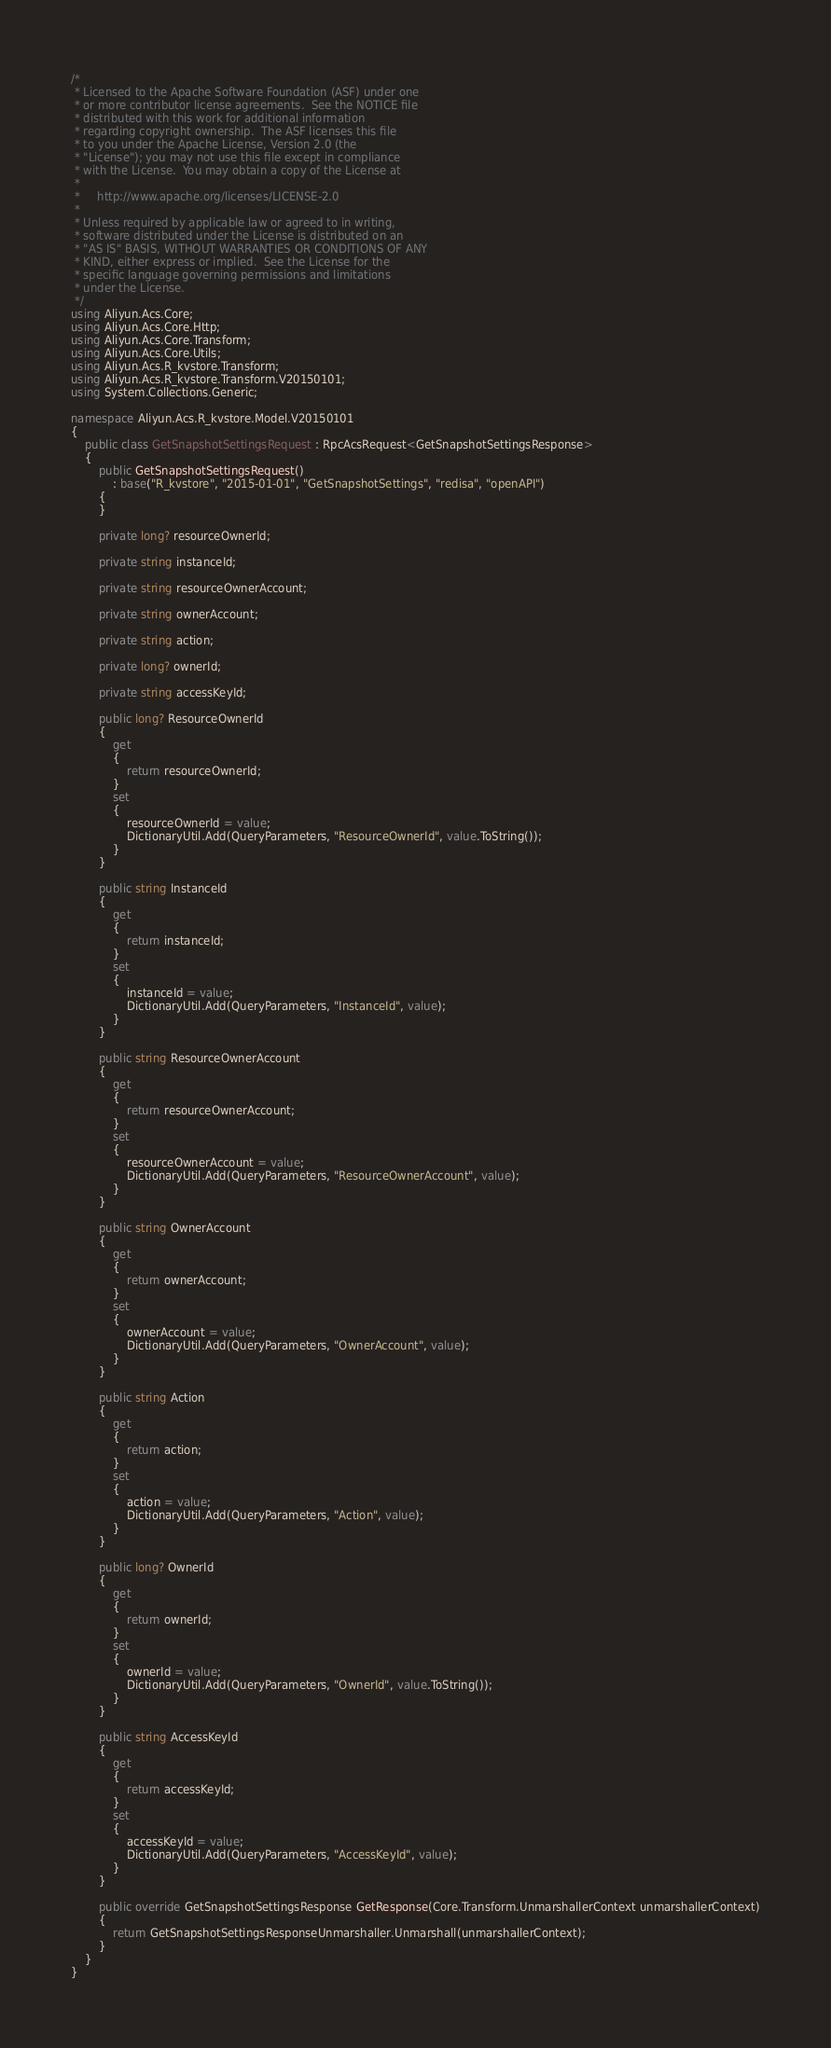<code> <loc_0><loc_0><loc_500><loc_500><_C#_>/*
 * Licensed to the Apache Software Foundation (ASF) under one
 * or more contributor license agreements.  See the NOTICE file
 * distributed with this work for additional information
 * regarding copyright ownership.  The ASF licenses this file
 * to you under the Apache License, Version 2.0 (the
 * "License"); you may not use this file except in compliance
 * with the License.  You may obtain a copy of the License at
 *
 *     http://www.apache.org/licenses/LICENSE-2.0
 *
 * Unless required by applicable law or agreed to in writing,
 * software distributed under the License is distributed on an
 * "AS IS" BASIS, WITHOUT WARRANTIES OR CONDITIONS OF ANY
 * KIND, either express or implied.  See the License for the
 * specific language governing permissions and limitations
 * under the License.
 */
using Aliyun.Acs.Core;
using Aliyun.Acs.Core.Http;
using Aliyun.Acs.Core.Transform;
using Aliyun.Acs.Core.Utils;
using Aliyun.Acs.R_kvstore.Transform;
using Aliyun.Acs.R_kvstore.Transform.V20150101;
using System.Collections.Generic;

namespace Aliyun.Acs.R_kvstore.Model.V20150101
{
    public class GetSnapshotSettingsRequest : RpcAcsRequest<GetSnapshotSettingsResponse>
    {
        public GetSnapshotSettingsRequest()
            : base("R_kvstore", "2015-01-01", "GetSnapshotSettings", "redisa", "openAPI")
        {
        }

		private long? resourceOwnerId;

		private string instanceId;

		private string resourceOwnerAccount;

		private string ownerAccount;

		private string action;

		private long? ownerId;

		private string accessKeyId;

		public long? ResourceOwnerId
		{
			get
			{
				return resourceOwnerId;
			}
			set	
			{
				resourceOwnerId = value;
				DictionaryUtil.Add(QueryParameters, "ResourceOwnerId", value.ToString());
			}
		}

		public string InstanceId
		{
			get
			{
				return instanceId;
			}
			set	
			{
				instanceId = value;
				DictionaryUtil.Add(QueryParameters, "InstanceId", value);
			}
		}

		public string ResourceOwnerAccount
		{
			get
			{
				return resourceOwnerAccount;
			}
			set	
			{
				resourceOwnerAccount = value;
				DictionaryUtil.Add(QueryParameters, "ResourceOwnerAccount", value);
			}
		}

		public string OwnerAccount
		{
			get
			{
				return ownerAccount;
			}
			set	
			{
				ownerAccount = value;
				DictionaryUtil.Add(QueryParameters, "OwnerAccount", value);
			}
		}

		public string Action
		{
			get
			{
				return action;
			}
			set	
			{
				action = value;
				DictionaryUtil.Add(QueryParameters, "Action", value);
			}
		}

		public long? OwnerId
		{
			get
			{
				return ownerId;
			}
			set	
			{
				ownerId = value;
				DictionaryUtil.Add(QueryParameters, "OwnerId", value.ToString());
			}
		}

		public string AccessKeyId
		{
			get
			{
				return accessKeyId;
			}
			set	
			{
				accessKeyId = value;
				DictionaryUtil.Add(QueryParameters, "AccessKeyId", value);
			}
		}

        public override GetSnapshotSettingsResponse GetResponse(Core.Transform.UnmarshallerContext unmarshallerContext)
        {
            return GetSnapshotSettingsResponseUnmarshaller.Unmarshall(unmarshallerContext);
        }
    }
}</code> 